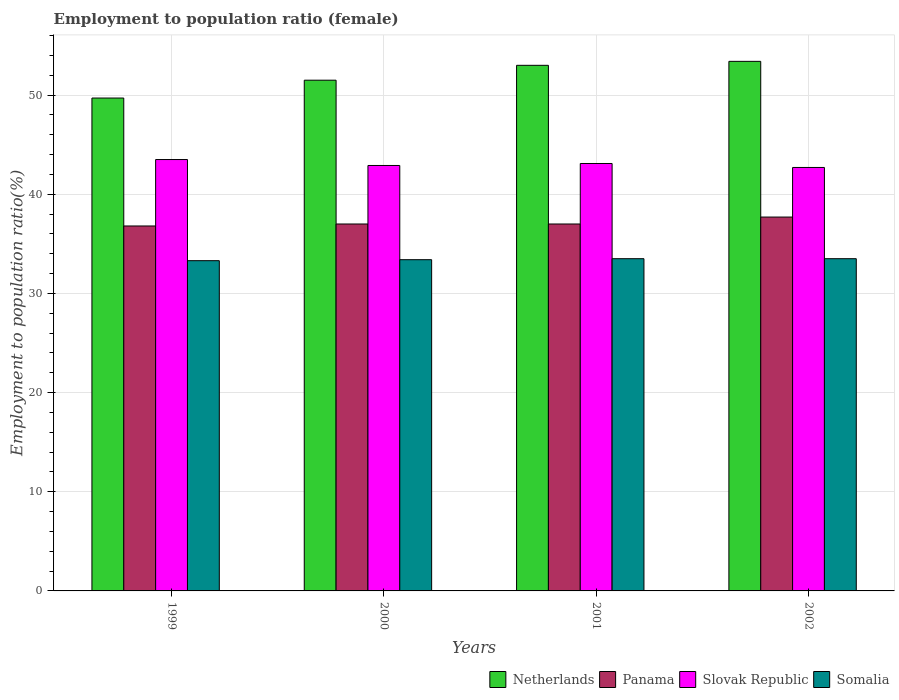How many different coloured bars are there?
Provide a short and direct response. 4. How many groups of bars are there?
Ensure brevity in your answer.  4. Are the number of bars on each tick of the X-axis equal?
Make the answer very short. Yes. How many bars are there on the 4th tick from the left?
Give a very brief answer. 4. In how many cases, is the number of bars for a given year not equal to the number of legend labels?
Provide a short and direct response. 0. What is the employment to population ratio in Panama in 2000?
Make the answer very short. 37. Across all years, what is the maximum employment to population ratio in Slovak Republic?
Give a very brief answer. 43.5. Across all years, what is the minimum employment to population ratio in Slovak Republic?
Your response must be concise. 42.7. In which year was the employment to population ratio in Somalia maximum?
Your response must be concise. 2001. What is the total employment to population ratio in Somalia in the graph?
Provide a succinct answer. 133.7. What is the difference between the employment to population ratio in Netherlands in 1999 and that in 2001?
Your answer should be very brief. -3.3. What is the difference between the employment to population ratio in Slovak Republic in 2000 and the employment to population ratio in Somalia in 1999?
Offer a terse response. 9.6. What is the average employment to population ratio in Panama per year?
Make the answer very short. 37.12. In the year 2001, what is the difference between the employment to population ratio in Somalia and employment to population ratio in Netherlands?
Make the answer very short. -19.5. What is the ratio of the employment to population ratio in Panama in 2000 to that in 2002?
Offer a terse response. 0.98. Is the employment to population ratio in Netherlands in 2001 less than that in 2002?
Offer a terse response. Yes. What is the difference between the highest and the second highest employment to population ratio in Panama?
Keep it short and to the point. 0.7. What is the difference between the highest and the lowest employment to population ratio in Somalia?
Give a very brief answer. 0.2. Is it the case that in every year, the sum of the employment to population ratio in Panama and employment to population ratio in Netherlands is greater than the sum of employment to population ratio in Somalia and employment to population ratio in Slovak Republic?
Keep it short and to the point. No. What does the 3rd bar from the left in 2002 represents?
Your answer should be compact. Slovak Republic. What does the 1st bar from the right in 2000 represents?
Ensure brevity in your answer.  Somalia. How many bars are there?
Offer a terse response. 16. Are all the bars in the graph horizontal?
Keep it short and to the point. No. Are the values on the major ticks of Y-axis written in scientific E-notation?
Your answer should be compact. No. Does the graph contain any zero values?
Your answer should be very brief. No. Does the graph contain grids?
Provide a short and direct response. Yes. Where does the legend appear in the graph?
Provide a succinct answer. Bottom right. How many legend labels are there?
Make the answer very short. 4. What is the title of the graph?
Ensure brevity in your answer.  Employment to population ratio (female). What is the label or title of the X-axis?
Offer a terse response. Years. What is the label or title of the Y-axis?
Make the answer very short. Employment to population ratio(%). What is the Employment to population ratio(%) of Netherlands in 1999?
Offer a very short reply. 49.7. What is the Employment to population ratio(%) in Panama in 1999?
Provide a succinct answer. 36.8. What is the Employment to population ratio(%) in Slovak Republic in 1999?
Offer a very short reply. 43.5. What is the Employment to population ratio(%) of Somalia in 1999?
Your answer should be compact. 33.3. What is the Employment to population ratio(%) in Netherlands in 2000?
Your answer should be compact. 51.5. What is the Employment to population ratio(%) in Slovak Republic in 2000?
Offer a terse response. 42.9. What is the Employment to population ratio(%) in Somalia in 2000?
Your response must be concise. 33.4. What is the Employment to population ratio(%) of Panama in 2001?
Your answer should be very brief. 37. What is the Employment to population ratio(%) of Slovak Republic in 2001?
Your answer should be compact. 43.1. What is the Employment to population ratio(%) in Somalia in 2001?
Offer a very short reply. 33.5. What is the Employment to population ratio(%) of Netherlands in 2002?
Offer a very short reply. 53.4. What is the Employment to population ratio(%) of Panama in 2002?
Ensure brevity in your answer.  37.7. What is the Employment to population ratio(%) of Slovak Republic in 2002?
Make the answer very short. 42.7. What is the Employment to population ratio(%) of Somalia in 2002?
Offer a very short reply. 33.5. Across all years, what is the maximum Employment to population ratio(%) in Netherlands?
Your response must be concise. 53.4. Across all years, what is the maximum Employment to population ratio(%) in Panama?
Keep it short and to the point. 37.7. Across all years, what is the maximum Employment to population ratio(%) in Slovak Republic?
Your answer should be very brief. 43.5. Across all years, what is the maximum Employment to population ratio(%) of Somalia?
Your answer should be compact. 33.5. Across all years, what is the minimum Employment to population ratio(%) in Netherlands?
Keep it short and to the point. 49.7. Across all years, what is the minimum Employment to population ratio(%) of Panama?
Give a very brief answer. 36.8. Across all years, what is the minimum Employment to population ratio(%) of Slovak Republic?
Ensure brevity in your answer.  42.7. Across all years, what is the minimum Employment to population ratio(%) in Somalia?
Keep it short and to the point. 33.3. What is the total Employment to population ratio(%) in Netherlands in the graph?
Ensure brevity in your answer.  207.6. What is the total Employment to population ratio(%) in Panama in the graph?
Your answer should be compact. 148.5. What is the total Employment to population ratio(%) of Slovak Republic in the graph?
Provide a short and direct response. 172.2. What is the total Employment to population ratio(%) in Somalia in the graph?
Provide a succinct answer. 133.7. What is the difference between the Employment to population ratio(%) of Panama in 1999 and that in 2000?
Your answer should be very brief. -0.2. What is the difference between the Employment to population ratio(%) in Slovak Republic in 1999 and that in 2000?
Your response must be concise. 0.6. What is the difference between the Employment to population ratio(%) in Somalia in 1999 and that in 2000?
Give a very brief answer. -0.1. What is the difference between the Employment to population ratio(%) in Slovak Republic in 1999 and that in 2001?
Provide a succinct answer. 0.4. What is the difference between the Employment to population ratio(%) of Somalia in 1999 and that in 2002?
Offer a very short reply. -0.2. What is the difference between the Employment to population ratio(%) of Panama in 2000 and that in 2001?
Ensure brevity in your answer.  0. What is the difference between the Employment to population ratio(%) in Slovak Republic in 2000 and that in 2001?
Offer a terse response. -0.2. What is the difference between the Employment to population ratio(%) in Somalia in 2000 and that in 2001?
Keep it short and to the point. -0.1. What is the difference between the Employment to population ratio(%) of Netherlands in 2000 and that in 2002?
Your response must be concise. -1.9. What is the difference between the Employment to population ratio(%) of Slovak Republic in 2000 and that in 2002?
Ensure brevity in your answer.  0.2. What is the difference between the Employment to population ratio(%) in Netherlands in 2001 and that in 2002?
Your answer should be compact. -0.4. What is the difference between the Employment to population ratio(%) of Netherlands in 1999 and the Employment to population ratio(%) of Slovak Republic in 2000?
Ensure brevity in your answer.  6.8. What is the difference between the Employment to population ratio(%) of Netherlands in 1999 and the Employment to population ratio(%) of Somalia in 2000?
Make the answer very short. 16.3. What is the difference between the Employment to population ratio(%) of Panama in 1999 and the Employment to population ratio(%) of Somalia in 2000?
Your response must be concise. 3.4. What is the difference between the Employment to population ratio(%) of Slovak Republic in 1999 and the Employment to population ratio(%) of Somalia in 2000?
Ensure brevity in your answer.  10.1. What is the difference between the Employment to population ratio(%) in Netherlands in 1999 and the Employment to population ratio(%) in Panama in 2001?
Offer a very short reply. 12.7. What is the difference between the Employment to population ratio(%) in Panama in 1999 and the Employment to population ratio(%) in Slovak Republic in 2001?
Your response must be concise. -6.3. What is the difference between the Employment to population ratio(%) of Slovak Republic in 1999 and the Employment to population ratio(%) of Somalia in 2001?
Ensure brevity in your answer.  10. What is the difference between the Employment to population ratio(%) of Netherlands in 1999 and the Employment to population ratio(%) of Panama in 2002?
Offer a terse response. 12. What is the difference between the Employment to population ratio(%) of Panama in 1999 and the Employment to population ratio(%) of Somalia in 2002?
Keep it short and to the point. 3.3. What is the difference between the Employment to population ratio(%) in Netherlands in 2000 and the Employment to population ratio(%) in Panama in 2001?
Your response must be concise. 14.5. What is the difference between the Employment to population ratio(%) in Netherlands in 2000 and the Employment to population ratio(%) in Somalia in 2001?
Provide a succinct answer. 18. What is the difference between the Employment to population ratio(%) of Panama in 2000 and the Employment to population ratio(%) of Slovak Republic in 2001?
Offer a terse response. -6.1. What is the difference between the Employment to population ratio(%) of Panama in 2000 and the Employment to population ratio(%) of Somalia in 2001?
Give a very brief answer. 3.5. What is the difference between the Employment to population ratio(%) in Netherlands in 2000 and the Employment to population ratio(%) in Somalia in 2002?
Give a very brief answer. 18. What is the difference between the Employment to population ratio(%) of Panama in 2000 and the Employment to population ratio(%) of Somalia in 2002?
Your response must be concise. 3.5. What is the difference between the Employment to population ratio(%) in Slovak Republic in 2000 and the Employment to population ratio(%) in Somalia in 2002?
Make the answer very short. 9.4. What is the difference between the Employment to population ratio(%) of Netherlands in 2001 and the Employment to population ratio(%) of Panama in 2002?
Offer a very short reply. 15.3. What is the difference between the Employment to population ratio(%) of Netherlands in 2001 and the Employment to population ratio(%) of Somalia in 2002?
Your answer should be compact. 19.5. What is the difference between the Employment to population ratio(%) in Panama in 2001 and the Employment to population ratio(%) in Slovak Republic in 2002?
Ensure brevity in your answer.  -5.7. What is the difference between the Employment to population ratio(%) in Panama in 2001 and the Employment to population ratio(%) in Somalia in 2002?
Ensure brevity in your answer.  3.5. What is the average Employment to population ratio(%) of Netherlands per year?
Your response must be concise. 51.9. What is the average Employment to population ratio(%) of Panama per year?
Your answer should be compact. 37.12. What is the average Employment to population ratio(%) in Slovak Republic per year?
Keep it short and to the point. 43.05. What is the average Employment to population ratio(%) in Somalia per year?
Ensure brevity in your answer.  33.42. In the year 1999, what is the difference between the Employment to population ratio(%) in Netherlands and Employment to population ratio(%) in Panama?
Provide a short and direct response. 12.9. In the year 1999, what is the difference between the Employment to population ratio(%) in Netherlands and Employment to population ratio(%) in Somalia?
Offer a very short reply. 16.4. In the year 1999, what is the difference between the Employment to population ratio(%) of Panama and Employment to population ratio(%) of Slovak Republic?
Offer a terse response. -6.7. In the year 1999, what is the difference between the Employment to population ratio(%) of Panama and Employment to population ratio(%) of Somalia?
Your answer should be very brief. 3.5. In the year 1999, what is the difference between the Employment to population ratio(%) of Slovak Republic and Employment to population ratio(%) of Somalia?
Your answer should be compact. 10.2. In the year 2000, what is the difference between the Employment to population ratio(%) of Slovak Republic and Employment to population ratio(%) of Somalia?
Make the answer very short. 9.5. In the year 2001, what is the difference between the Employment to population ratio(%) in Netherlands and Employment to population ratio(%) in Slovak Republic?
Provide a succinct answer. 9.9. In the year 2001, what is the difference between the Employment to population ratio(%) in Netherlands and Employment to population ratio(%) in Somalia?
Keep it short and to the point. 19.5. In the year 2001, what is the difference between the Employment to population ratio(%) of Panama and Employment to population ratio(%) of Slovak Republic?
Make the answer very short. -6.1. In the year 2001, what is the difference between the Employment to population ratio(%) of Slovak Republic and Employment to population ratio(%) of Somalia?
Keep it short and to the point. 9.6. In the year 2002, what is the difference between the Employment to population ratio(%) in Panama and Employment to population ratio(%) in Somalia?
Provide a short and direct response. 4.2. What is the ratio of the Employment to population ratio(%) in Netherlands in 1999 to that in 2000?
Your response must be concise. 0.96. What is the ratio of the Employment to population ratio(%) in Panama in 1999 to that in 2000?
Your answer should be compact. 0.99. What is the ratio of the Employment to population ratio(%) of Somalia in 1999 to that in 2000?
Give a very brief answer. 1. What is the ratio of the Employment to population ratio(%) in Netherlands in 1999 to that in 2001?
Your answer should be compact. 0.94. What is the ratio of the Employment to population ratio(%) of Slovak Republic in 1999 to that in 2001?
Your answer should be very brief. 1.01. What is the ratio of the Employment to population ratio(%) of Somalia in 1999 to that in 2001?
Offer a very short reply. 0.99. What is the ratio of the Employment to population ratio(%) of Netherlands in 1999 to that in 2002?
Provide a short and direct response. 0.93. What is the ratio of the Employment to population ratio(%) in Panama in 1999 to that in 2002?
Your answer should be very brief. 0.98. What is the ratio of the Employment to population ratio(%) in Slovak Republic in 1999 to that in 2002?
Give a very brief answer. 1.02. What is the ratio of the Employment to population ratio(%) of Netherlands in 2000 to that in 2001?
Give a very brief answer. 0.97. What is the ratio of the Employment to population ratio(%) in Slovak Republic in 2000 to that in 2001?
Provide a succinct answer. 1. What is the ratio of the Employment to population ratio(%) of Netherlands in 2000 to that in 2002?
Your answer should be very brief. 0.96. What is the ratio of the Employment to population ratio(%) in Panama in 2000 to that in 2002?
Offer a terse response. 0.98. What is the ratio of the Employment to population ratio(%) in Slovak Republic in 2000 to that in 2002?
Your answer should be very brief. 1. What is the ratio of the Employment to population ratio(%) of Panama in 2001 to that in 2002?
Offer a very short reply. 0.98. What is the ratio of the Employment to population ratio(%) in Slovak Republic in 2001 to that in 2002?
Your answer should be very brief. 1.01. What is the difference between the highest and the lowest Employment to population ratio(%) in Slovak Republic?
Make the answer very short. 0.8. What is the difference between the highest and the lowest Employment to population ratio(%) of Somalia?
Keep it short and to the point. 0.2. 